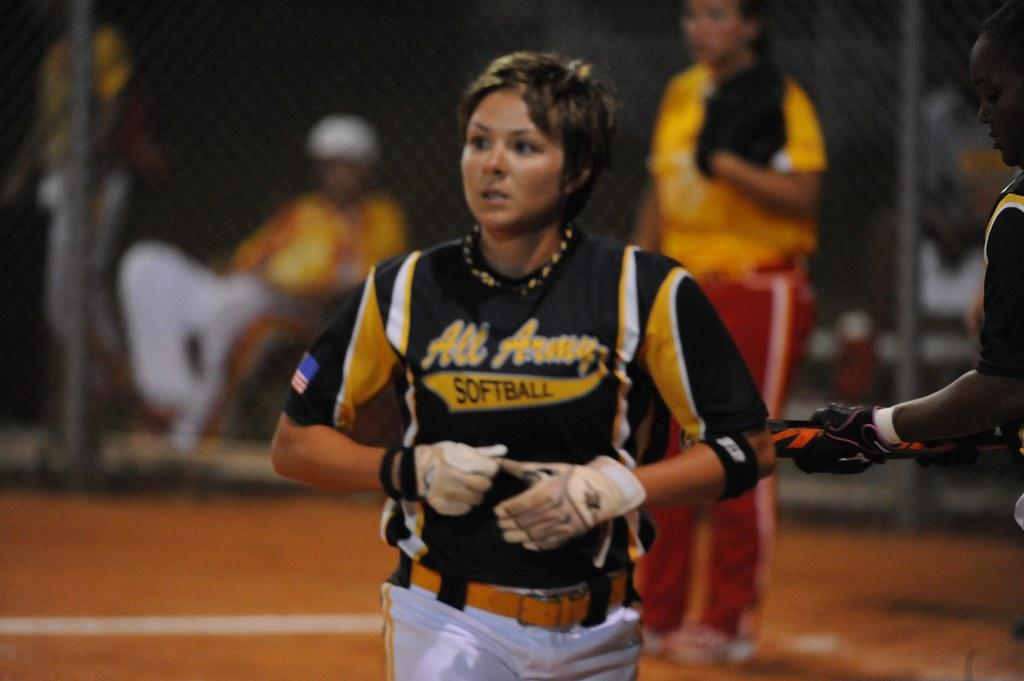<image>
Provide a brief description of the given image. An All Army softball player is about to take off her glove. 